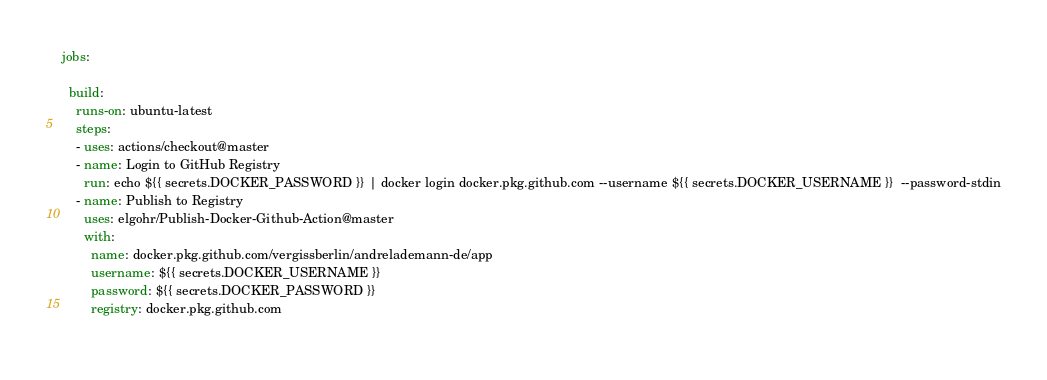<code> <loc_0><loc_0><loc_500><loc_500><_YAML_>jobs:

  build:
    runs-on: ubuntu-latest
    steps:
    - uses: actions/checkout@master
    - name: Login to GitHub Registry
      run: echo ${{ secrets.DOCKER_PASSWORD }} | docker login docker.pkg.github.com --username ${{ secrets.DOCKER_USERNAME }}  --password-stdin
    - name: Publish to Registry
      uses: elgohr/Publish-Docker-Github-Action@master
      with:
        name: docker.pkg.github.com/vergissberlin/andrelademann-de/app
        username: ${{ secrets.DOCKER_USERNAME }}
        password: ${{ secrets.DOCKER_PASSWORD }}
        registry: docker.pkg.github.com
    
</code> 